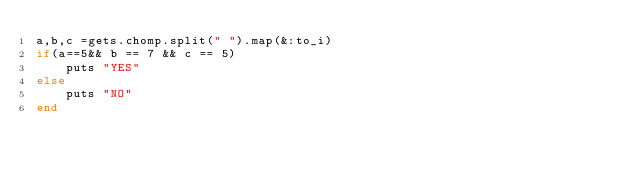<code> <loc_0><loc_0><loc_500><loc_500><_Ruby_>a,b,c =gets.chomp.split(" ").map(&:to_i)
if(a==5&& b == 7 && c == 5)
    puts "YES"
else
    puts "NO"
end</code> 